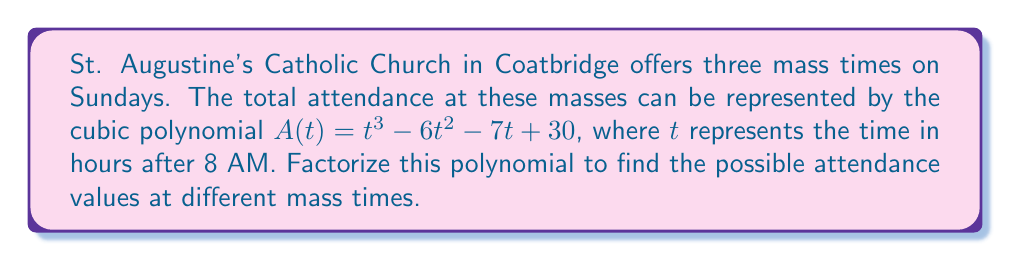Show me your answer to this math problem. To factorize the cubic polynomial $A(t) = t^3 - 6t^2 - 7t + 30$, we'll follow these steps:

1) First, let's check if there's a common factor. In this case, there isn't.

2) Next, we'll try to guess one factor. Let's check for rational roots using the factors of the constant term (30): ±1, ±2, ±3, ±5, ±6, ±10, ±15, ±30.

3) Testing these values, we find that $t = 5$ is a root (i.e., $A(5) = 0$).

4) So, $(t - 5)$ is a factor. We can use polynomial long division to find the other factor:

   $t^3 - 6t^2 - 7t + 30 = (t - 5)(t^2 + at + b)$

5) Performing the division:
   
   $t^3 - 6t^2 - 7t + 30 = (t - 5)(t^2 + 5t - 6)$

6) We can further factorize $t^2 + 5t - 6$ using the quadratic formula or by inspection:

   $t^2 + 5t - 6 = (t + 6)(t - 1)$

7) Therefore, the complete factorization is:

   $A(t) = (t - 5)(t + 6)(t - 1)$

This factorization gives us the three possible times when the attendance could be zero (if extended to non-realistic times), or the times when attendance is changing from increasing to decreasing or vice versa.
Answer: $A(t) = (t - 5)(t + 6)(t - 1)$ 